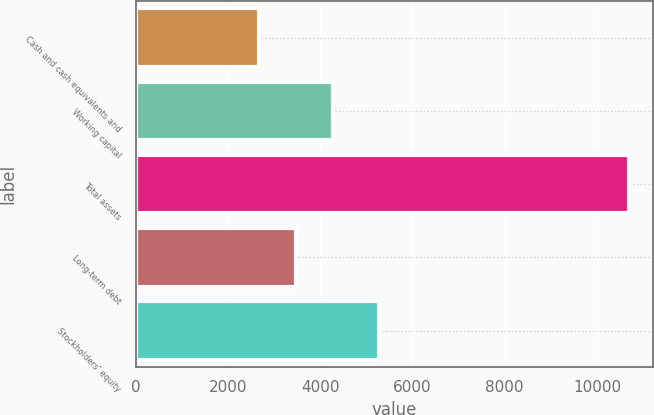Convert chart to OTSL. <chart><loc_0><loc_0><loc_500><loc_500><bar_chart><fcel>Cash and cash equivalents and<fcel>Working capital<fcel>Total assets<fcel>Long-term debt<fcel>Stockholders' equity<nl><fcel>2675<fcel>4277.2<fcel>10686<fcel>3476.1<fcel>5286<nl></chart> 